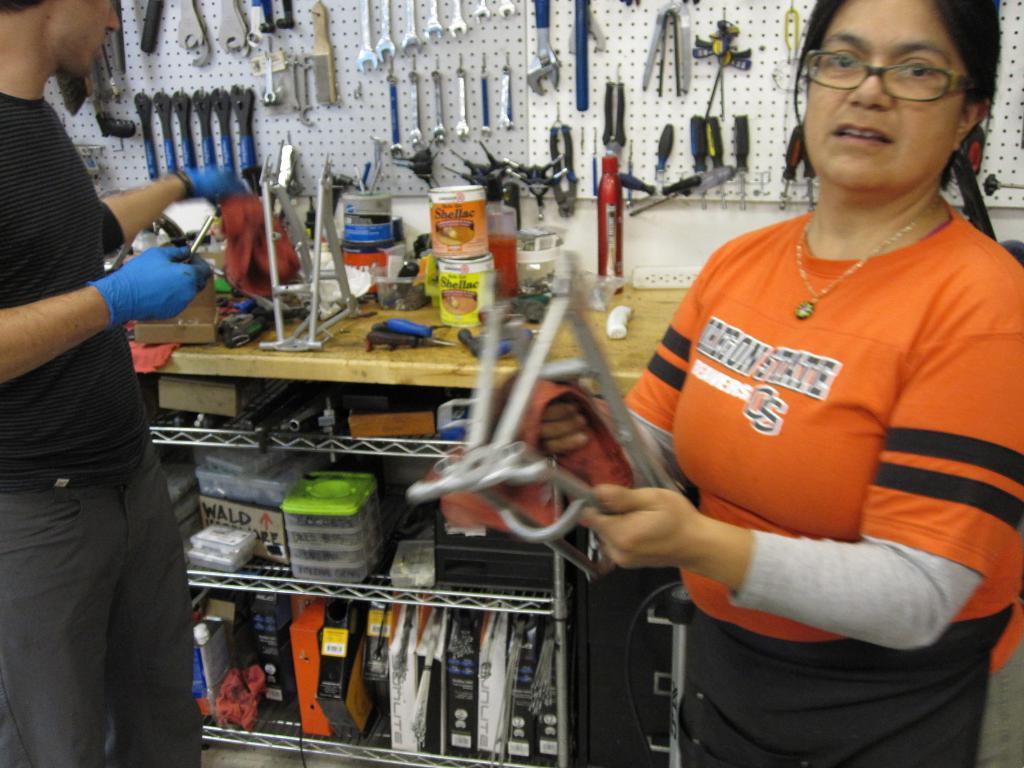Could you give a brief overview of what you see in this image? In the image we can see there is a woman standing and she is holding iron rods in her hand. Beside there is another man standing and there are other iron equipments kept on the board. 